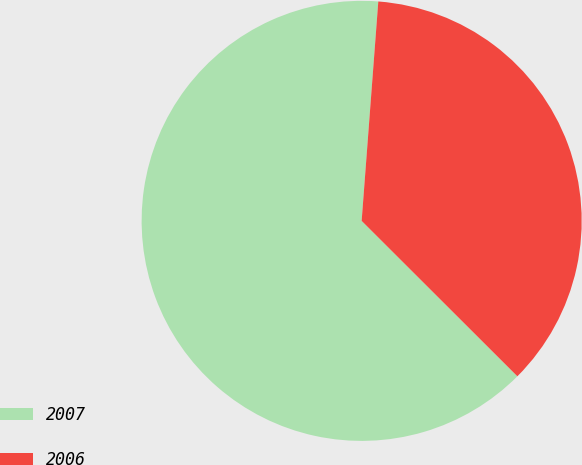<chart> <loc_0><loc_0><loc_500><loc_500><pie_chart><fcel>2007<fcel>2006<nl><fcel>63.72%<fcel>36.28%<nl></chart> 